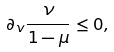Convert formula to latex. <formula><loc_0><loc_0><loc_500><loc_500>\partial _ { v } \frac { \nu } { 1 - \mu } \leq 0 ,</formula> 